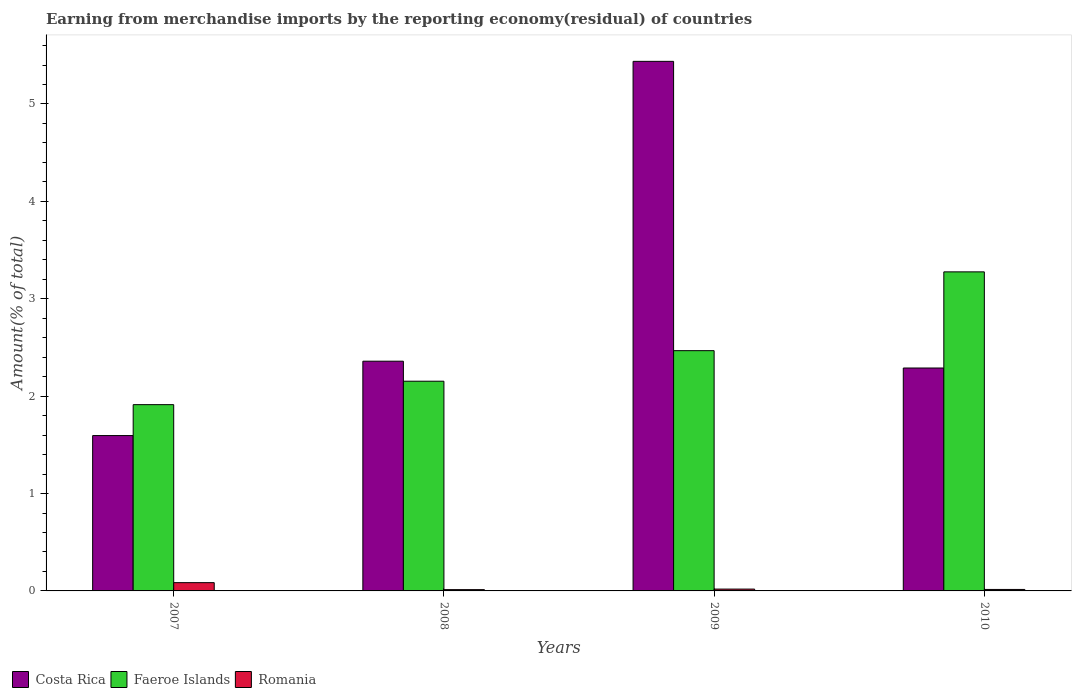Are the number of bars per tick equal to the number of legend labels?
Ensure brevity in your answer.  Yes. What is the label of the 3rd group of bars from the left?
Make the answer very short. 2009. What is the percentage of amount earned from merchandise imports in Costa Rica in 2010?
Ensure brevity in your answer.  2.29. Across all years, what is the maximum percentage of amount earned from merchandise imports in Faeroe Islands?
Offer a very short reply. 3.28. Across all years, what is the minimum percentage of amount earned from merchandise imports in Romania?
Your answer should be compact. 0.01. In which year was the percentage of amount earned from merchandise imports in Faeroe Islands maximum?
Ensure brevity in your answer.  2010. In which year was the percentage of amount earned from merchandise imports in Romania minimum?
Your answer should be compact. 2008. What is the total percentage of amount earned from merchandise imports in Romania in the graph?
Provide a succinct answer. 0.13. What is the difference between the percentage of amount earned from merchandise imports in Faeroe Islands in 2007 and that in 2008?
Make the answer very short. -0.24. What is the difference between the percentage of amount earned from merchandise imports in Costa Rica in 2007 and the percentage of amount earned from merchandise imports in Faeroe Islands in 2010?
Make the answer very short. -1.68. What is the average percentage of amount earned from merchandise imports in Faeroe Islands per year?
Ensure brevity in your answer.  2.45. In the year 2009, what is the difference between the percentage of amount earned from merchandise imports in Faeroe Islands and percentage of amount earned from merchandise imports in Romania?
Ensure brevity in your answer.  2.45. In how many years, is the percentage of amount earned from merchandise imports in Costa Rica greater than 2.6 %?
Ensure brevity in your answer.  1. What is the ratio of the percentage of amount earned from merchandise imports in Faeroe Islands in 2009 to that in 2010?
Offer a terse response. 0.75. What is the difference between the highest and the second highest percentage of amount earned from merchandise imports in Romania?
Provide a short and direct response. 0.07. What is the difference between the highest and the lowest percentage of amount earned from merchandise imports in Romania?
Make the answer very short. 0.07. What does the 3rd bar from the left in 2008 represents?
Provide a succinct answer. Romania. What does the 1st bar from the right in 2008 represents?
Provide a short and direct response. Romania. How many bars are there?
Give a very brief answer. 12. Are all the bars in the graph horizontal?
Offer a very short reply. No. What is the difference between two consecutive major ticks on the Y-axis?
Your answer should be very brief. 1. Are the values on the major ticks of Y-axis written in scientific E-notation?
Provide a short and direct response. No. What is the title of the graph?
Your response must be concise. Earning from merchandise imports by the reporting economy(residual) of countries. What is the label or title of the X-axis?
Keep it short and to the point. Years. What is the label or title of the Y-axis?
Keep it short and to the point. Amount(% of total). What is the Amount(% of total) in Costa Rica in 2007?
Make the answer very short. 1.6. What is the Amount(% of total) of Faeroe Islands in 2007?
Your response must be concise. 1.91. What is the Amount(% of total) of Romania in 2007?
Ensure brevity in your answer.  0.08. What is the Amount(% of total) of Costa Rica in 2008?
Give a very brief answer. 2.36. What is the Amount(% of total) in Faeroe Islands in 2008?
Offer a terse response. 2.15. What is the Amount(% of total) in Romania in 2008?
Keep it short and to the point. 0.01. What is the Amount(% of total) in Costa Rica in 2009?
Your answer should be compact. 5.44. What is the Amount(% of total) of Faeroe Islands in 2009?
Make the answer very short. 2.47. What is the Amount(% of total) of Romania in 2009?
Ensure brevity in your answer.  0.02. What is the Amount(% of total) of Costa Rica in 2010?
Provide a short and direct response. 2.29. What is the Amount(% of total) of Faeroe Islands in 2010?
Your response must be concise. 3.28. What is the Amount(% of total) of Romania in 2010?
Offer a very short reply. 0.02. Across all years, what is the maximum Amount(% of total) in Costa Rica?
Provide a succinct answer. 5.44. Across all years, what is the maximum Amount(% of total) of Faeroe Islands?
Your answer should be very brief. 3.28. Across all years, what is the maximum Amount(% of total) in Romania?
Your response must be concise. 0.08. Across all years, what is the minimum Amount(% of total) of Costa Rica?
Your answer should be very brief. 1.6. Across all years, what is the minimum Amount(% of total) in Faeroe Islands?
Keep it short and to the point. 1.91. Across all years, what is the minimum Amount(% of total) in Romania?
Your answer should be very brief. 0.01. What is the total Amount(% of total) of Costa Rica in the graph?
Your response must be concise. 11.68. What is the total Amount(% of total) in Faeroe Islands in the graph?
Offer a very short reply. 9.81. What is the total Amount(% of total) of Romania in the graph?
Offer a very short reply. 0.13. What is the difference between the Amount(% of total) in Costa Rica in 2007 and that in 2008?
Keep it short and to the point. -0.76. What is the difference between the Amount(% of total) of Faeroe Islands in 2007 and that in 2008?
Keep it short and to the point. -0.24. What is the difference between the Amount(% of total) in Romania in 2007 and that in 2008?
Your response must be concise. 0.07. What is the difference between the Amount(% of total) of Costa Rica in 2007 and that in 2009?
Your answer should be very brief. -3.84. What is the difference between the Amount(% of total) in Faeroe Islands in 2007 and that in 2009?
Give a very brief answer. -0.55. What is the difference between the Amount(% of total) of Romania in 2007 and that in 2009?
Offer a terse response. 0.07. What is the difference between the Amount(% of total) of Costa Rica in 2007 and that in 2010?
Ensure brevity in your answer.  -0.69. What is the difference between the Amount(% of total) in Faeroe Islands in 2007 and that in 2010?
Offer a very short reply. -1.36. What is the difference between the Amount(% of total) of Romania in 2007 and that in 2010?
Offer a terse response. 0.07. What is the difference between the Amount(% of total) of Costa Rica in 2008 and that in 2009?
Offer a very short reply. -3.08. What is the difference between the Amount(% of total) in Faeroe Islands in 2008 and that in 2009?
Your answer should be compact. -0.31. What is the difference between the Amount(% of total) of Romania in 2008 and that in 2009?
Keep it short and to the point. -0.01. What is the difference between the Amount(% of total) in Costa Rica in 2008 and that in 2010?
Give a very brief answer. 0.07. What is the difference between the Amount(% of total) in Faeroe Islands in 2008 and that in 2010?
Provide a succinct answer. -1.12. What is the difference between the Amount(% of total) of Romania in 2008 and that in 2010?
Make the answer very short. -0. What is the difference between the Amount(% of total) of Costa Rica in 2009 and that in 2010?
Give a very brief answer. 3.15. What is the difference between the Amount(% of total) in Faeroe Islands in 2009 and that in 2010?
Keep it short and to the point. -0.81. What is the difference between the Amount(% of total) of Romania in 2009 and that in 2010?
Make the answer very short. 0. What is the difference between the Amount(% of total) in Costa Rica in 2007 and the Amount(% of total) in Faeroe Islands in 2008?
Give a very brief answer. -0.56. What is the difference between the Amount(% of total) of Costa Rica in 2007 and the Amount(% of total) of Romania in 2008?
Ensure brevity in your answer.  1.58. What is the difference between the Amount(% of total) of Faeroe Islands in 2007 and the Amount(% of total) of Romania in 2008?
Your response must be concise. 1.9. What is the difference between the Amount(% of total) of Costa Rica in 2007 and the Amount(% of total) of Faeroe Islands in 2009?
Your answer should be compact. -0.87. What is the difference between the Amount(% of total) of Costa Rica in 2007 and the Amount(% of total) of Romania in 2009?
Offer a terse response. 1.58. What is the difference between the Amount(% of total) of Faeroe Islands in 2007 and the Amount(% of total) of Romania in 2009?
Your answer should be compact. 1.89. What is the difference between the Amount(% of total) of Costa Rica in 2007 and the Amount(% of total) of Faeroe Islands in 2010?
Provide a short and direct response. -1.68. What is the difference between the Amount(% of total) in Costa Rica in 2007 and the Amount(% of total) in Romania in 2010?
Ensure brevity in your answer.  1.58. What is the difference between the Amount(% of total) in Faeroe Islands in 2007 and the Amount(% of total) in Romania in 2010?
Your response must be concise. 1.9. What is the difference between the Amount(% of total) in Costa Rica in 2008 and the Amount(% of total) in Faeroe Islands in 2009?
Make the answer very short. -0.11. What is the difference between the Amount(% of total) of Costa Rica in 2008 and the Amount(% of total) of Romania in 2009?
Provide a short and direct response. 2.34. What is the difference between the Amount(% of total) in Faeroe Islands in 2008 and the Amount(% of total) in Romania in 2009?
Your answer should be compact. 2.13. What is the difference between the Amount(% of total) of Costa Rica in 2008 and the Amount(% of total) of Faeroe Islands in 2010?
Offer a terse response. -0.92. What is the difference between the Amount(% of total) in Costa Rica in 2008 and the Amount(% of total) in Romania in 2010?
Make the answer very short. 2.34. What is the difference between the Amount(% of total) in Faeroe Islands in 2008 and the Amount(% of total) in Romania in 2010?
Offer a terse response. 2.14. What is the difference between the Amount(% of total) of Costa Rica in 2009 and the Amount(% of total) of Faeroe Islands in 2010?
Your answer should be compact. 2.16. What is the difference between the Amount(% of total) of Costa Rica in 2009 and the Amount(% of total) of Romania in 2010?
Ensure brevity in your answer.  5.42. What is the difference between the Amount(% of total) of Faeroe Islands in 2009 and the Amount(% of total) of Romania in 2010?
Offer a terse response. 2.45. What is the average Amount(% of total) in Costa Rica per year?
Ensure brevity in your answer.  2.92. What is the average Amount(% of total) of Faeroe Islands per year?
Ensure brevity in your answer.  2.45. What is the average Amount(% of total) of Romania per year?
Keep it short and to the point. 0.03. In the year 2007, what is the difference between the Amount(% of total) of Costa Rica and Amount(% of total) of Faeroe Islands?
Your answer should be compact. -0.32. In the year 2007, what is the difference between the Amount(% of total) in Costa Rica and Amount(% of total) in Romania?
Give a very brief answer. 1.51. In the year 2007, what is the difference between the Amount(% of total) in Faeroe Islands and Amount(% of total) in Romania?
Your answer should be compact. 1.83. In the year 2008, what is the difference between the Amount(% of total) in Costa Rica and Amount(% of total) in Faeroe Islands?
Your response must be concise. 0.21. In the year 2008, what is the difference between the Amount(% of total) of Costa Rica and Amount(% of total) of Romania?
Offer a terse response. 2.35. In the year 2008, what is the difference between the Amount(% of total) in Faeroe Islands and Amount(% of total) in Romania?
Give a very brief answer. 2.14. In the year 2009, what is the difference between the Amount(% of total) of Costa Rica and Amount(% of total) of Faeroe Islands?
Offer a terse response. 2.97. In the year 2009, what is the difference between the Amount(% of total) in Costa Rica and Amount(% of total) in Romania?
Your answer should be very brief. 5.42. In the year 2009, what is the difference between the Amount(% of total) in Faeroe Islands and Amount(% of total) in Romania?
Make the answer very short. 2.45. In the year 2010, what is the difference between the Amount(% of total) of Costa Rica and Amount(% of total) of Faeroe Islands?
Provide a short and direct response. -0.99. In the year 2010, what is the difference between the Amount(% of total) in Costa Rica and Amount(% of total) in Romania?
Provide a short and direct response. 2.27. In the year 2010, what is the difference between the Amount(% of total) in Faeroe Islands and Amount(% of total) in Romania?
Your response must be concise. 3.26. What is the ratio of the Amount(% of total) of Costa Rica in 2007 to that in 2008?
Make the answer very short. 0.68. What is the ratio of the Amount(% of total) of Faeroe Islands in 2007 to that in 2008?
Your answer should be very brief. 0.89. What is the ratio of the Amount(% of total) of Romania in 2007 to that in 2008?
Your answer should be very brief. 6.4. What is the ratio of the Amount(% of total) in Costa Rica in 2007 to that in 2009?
Your answer should be very brief. 0.29. What is the ratio of the Amount(% of total) of Faeroe Islands in 2007 to that in 2009?
Your answer should be very brief. 0.78. What is the ratio of the Amount(% of total) of Romania in 2007 to that in 2009?
Ensure brevity in your answer.  4.52. What is the ratio of the Amount(% of total) in Costa Rica in 2007 to that in 2010?
Your answer should be very brief. 0.7. What is the ratio of the Amount(% of total) in Faeroe Islands in 2007 to that in 2010?
Offer a very short reply. 0.58. What is the ratio of the Amount(% of total) of Romania in 2007 to that in 2010?
Provide a short and direct response. 5.59. What is the ratio of the Amount(% of total) of Costa Rica in 2008 to that in 2009?
Provide a short and direct response. 0.43. What is the ratio of the Amount(% of total) in Faeroe Islands in 2008 to that in 2009?
Make the answer very short. 0.87. What is the ratio of the Amount(% of total) of Romania in 2008 to that in 2009?
Your response must be concise. 0.71. What is the ratio of the Amount(% of total) in Costa Rica in 2008 to that in 2010?
Make the answer very short. 1.03. What is the ratio of the Amount(% of total) in Faeroe Islands in 2008 to that in 2010?
Ensure brevity in your answer.  0.66. What is the ratio of the Amount(% of total) in Romania in 2008 to that in 2010?
Offer a terse response. 0.87. What is the ratio of the Amount(% of total) in Costa Rica in 2009 to that in 2010?
Your answer should be compact. 2.38. What is the ratio of the Amount(% of total) in Faeroe Islands in 2009 to that in 2010?
Make the answer very short. 0.75. What is the ratio of the Amount(% of total) of Romania in 2009 to that in 2010?
Make the answer very short. 1.24. What is the difference between the highest and the second highest Amount(% of total) of Costa Rica?
Your response must be concise. 3.08. What is the difference between the highest and the second highest Amount(% of total) of Faeroe Islands?
Ensure brevity in your answer.  0.81. What is the difference between the highest and the second highest Amount(% of total) in Romania?
Ensure brevity in your answer.  0.07. What is the difference between the highest and the lowest Amount(% of total) in Costa Rica?
Offer a very short reply. 3.84. What is the difference between the highest and the lowest Amount(% of total) of Faeroe Islands?
Your answer should be very brief. 1.36. What is the difference between the highest and the lowest Amount(% of total) of Romania?
Give a very brief answer. 0.07. 